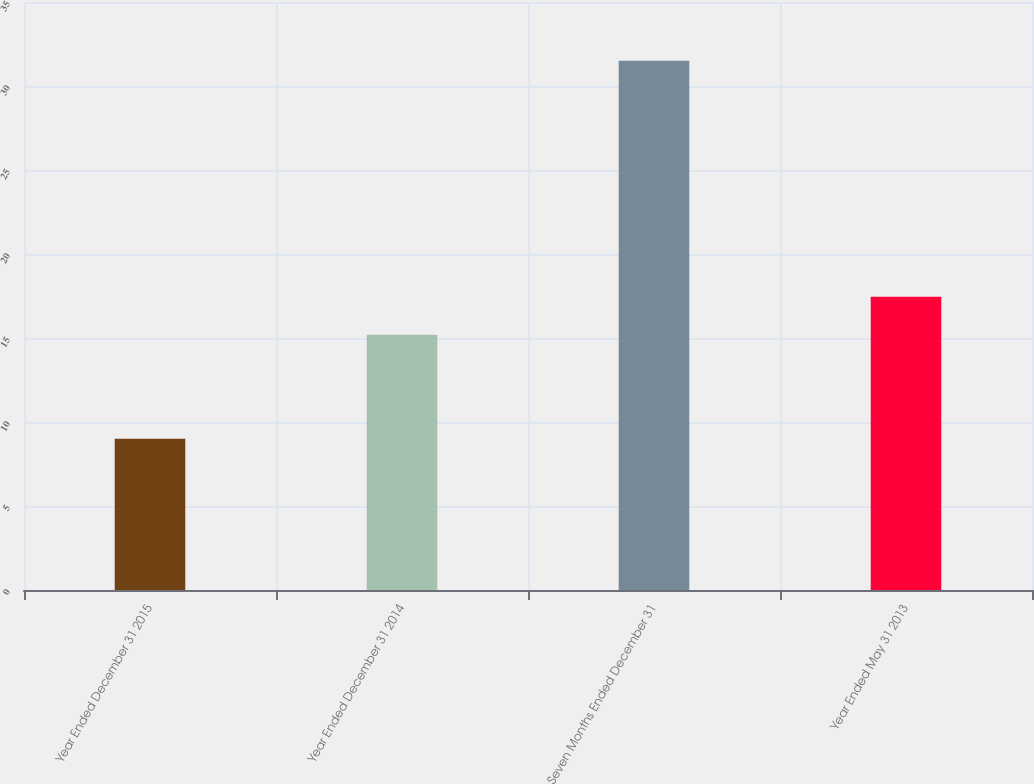<chart> <loc_0><loc_0><loc_500><loc_500><bar_chart><fcel>Year Ended December 31 2015<fcel>Year Ended December 31 2014<fcel>Seven Months Ended December 31<fcel>Year Ended May 31 2013<nl><fcel>9<fcel>15.2<fcel>31.5<fcel>17.45<nl></chart> 